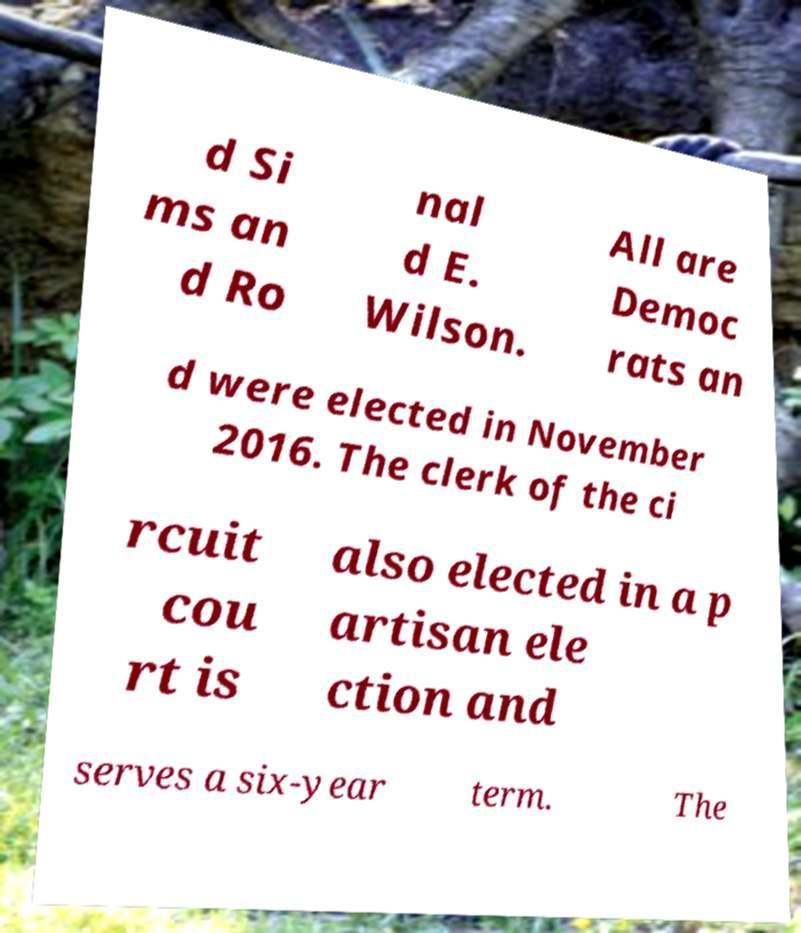Please identify and transcribe the text found in this image. d Si ms an d Ro nal d E. Wilson. All are Democ rats an d were elected in November 2016. The clerk of the ci rcuit cou rt is also elected in a p artisan ele ction and serves a six-year term. The 